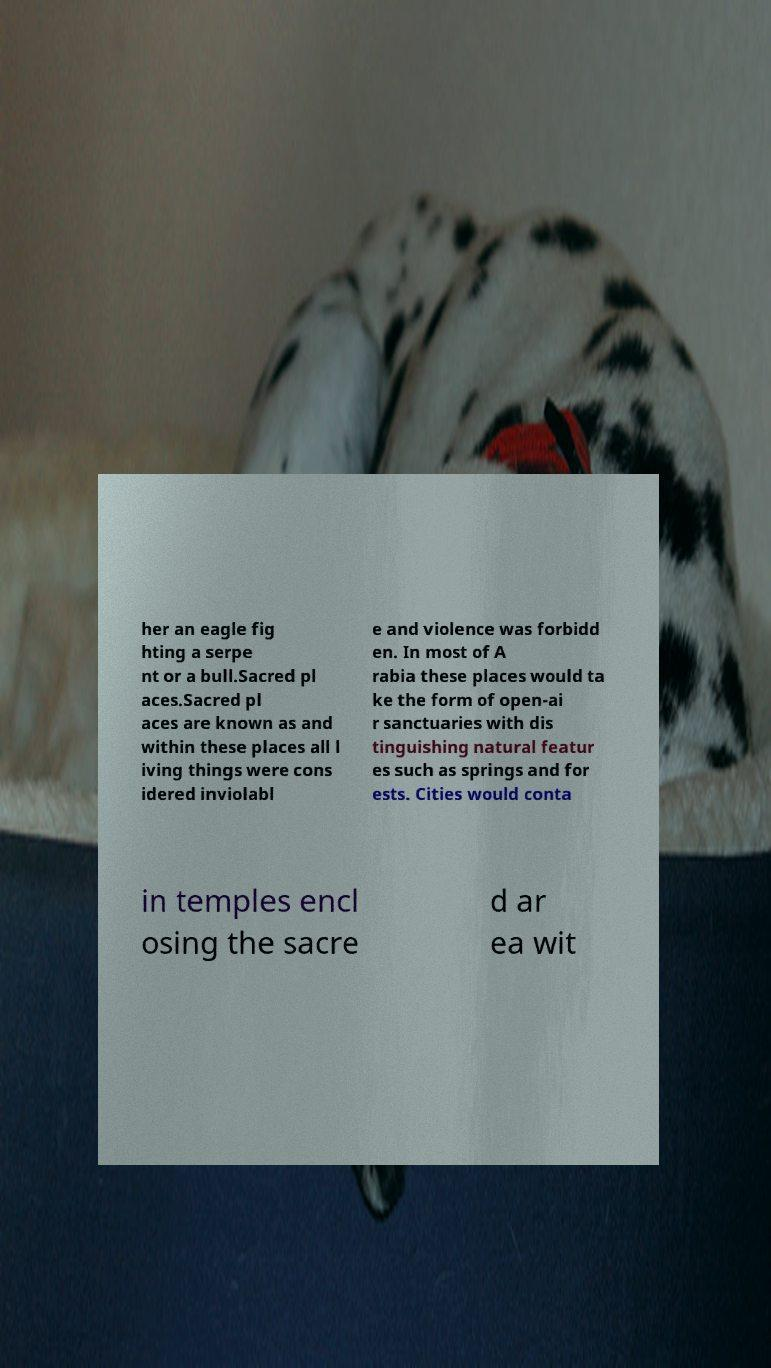I need the written content from this picture converted into text. Can you do that? her an eagle fig hting a serpe nt or a bull.Sacred pl aces.Sacred pl aces are known as and within these places all l iving things were cons idered inviolabl e and violence was forbidd en. In most of A rabia these places would ta ke the form of open-ai r sanctuaries with dis tinguishing natural featur es such as springs and for ests. Cities would conta in temples encl osing the sacre d ar ea wit 